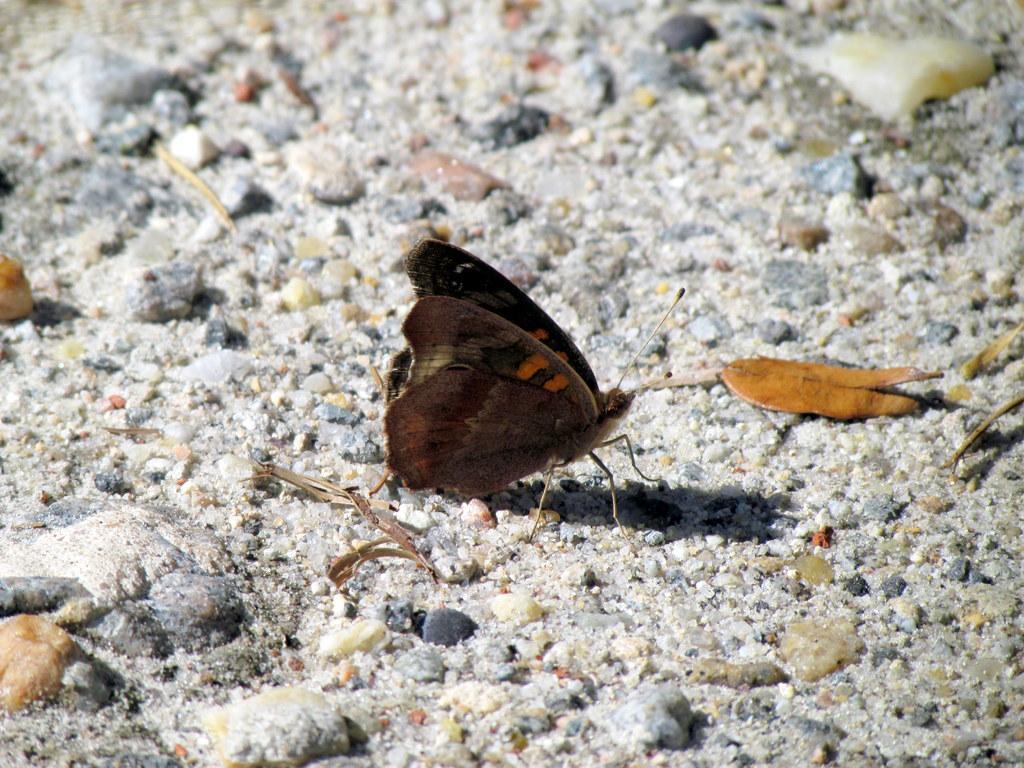In one or two sentences, can you explain what this image depicts? In this image there is a butterfly on the land having rocks. 